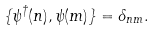Convert formula to latex. <formula><loc_0><loc_0><loc_500><loc_500>\{ \psi ^ { \dag } ( n ) , \psi ( m ) \} = \delta _ { n m } .</formula> 